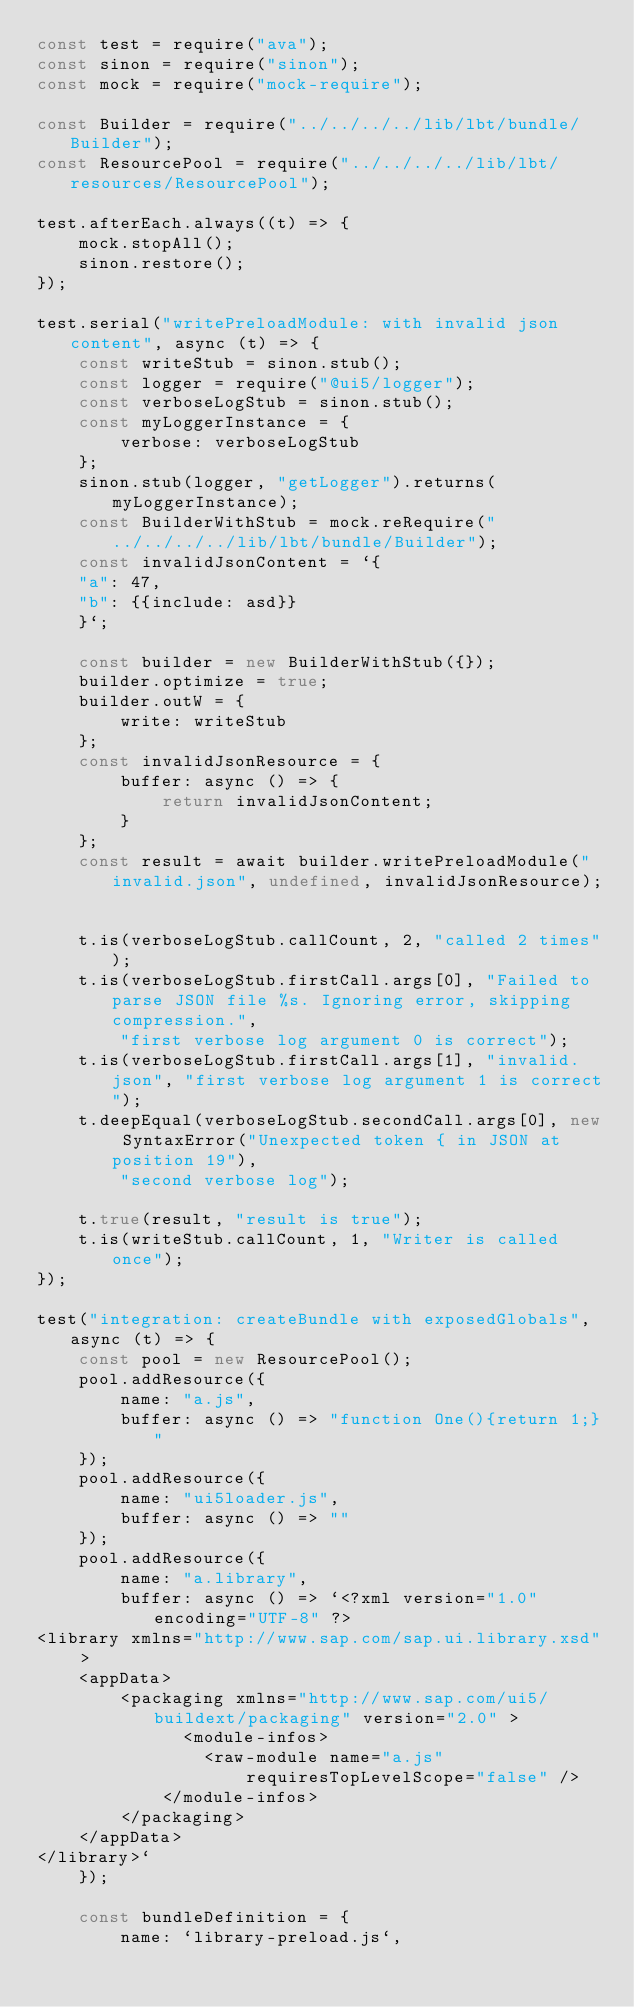<code> <loc_0><loc_0><loc_500><loc_500><_JavaScript_>const test = require("ava");
const sinon = require("sinon");
const mock = require("mock-require");

const Builder = require("../../../../lib/lbt/bundle/Builder");
const ResourcePool = require("../../../../lib/lbt/resources/ResourcePool");

test.afterEach.always((t) => {
	mock.stopAll();
	sinon.restore();
});

test.serial("writePreloadModule: with invalid json content", async (t) => {
	const writeStub = sinon.stub();
	const logger = require("@ui5/logger");
	const verboseLogStub = sinon.stub();
	const myLoggerInstance = {
		verbose: verboseLogStub
	};
	sinon.stub(logger, "getLogger").returns(myLoggerInstance);
	const BuilderWithStub = mock.reRequire("../../../../lib/lbt/bundle/Builder");
	const invalidJsonContent = `{
	"a": 47,
	"b": {{include: asd}}
	}`;

	const builder = new BuilderWithStub({});
	builder.optimize = true;
	builder.outW = {
		write: writeStub
	};
	const invalidJsonResource = {
		buffer: async () => {
			return invalidJsonContent;
		}
	};
	const result = await builder.writePreloadModule("invalid.json", undefined, invalidJsonResource);


	t.is(verboseLogStub.callCount, 2, "called 2 times");
	t.is(verboseLogStub.firstCall.args[0], "Failed to parse JSON file %s. Ignoring error, skipping compression.",
		"first verbose log argument 0 is correct");
	t.is(verboseLogStub.firstCall.args[1], "invalid.json", "first verbose log argument 1 is correct");
	t.deepEqual(verboseLogStub.secondCall.args[0], new SyntaxError("Unexpected token { in JSON at position 19"),
		"second verbose log");

	t.true(result, "result is true");
	t.is(writeStub.callCount, 1, "Writer is called once");
});

test("integration: createBundle with exposedGlobals", async (t) => {
	const pool = new ResourcePool();
	pool.addResource({
		name: "a.js",
		buffer: async () => "function One(){return 1;}"
	});
	pool.addResource({
		name: "ui5loader.js",
		buffer: async () => ""
	});
	pool.addResource({
		name: "a.library",
		buffer: async () => `<?xml version="1.0" encoding="UTF-8" ?>
<library xmlns="http://www.sap.com/sap.ui.library.xsd" >
	<appData>
		<packaging xmlns="http://www.sap.com/ui5/buildext/packaging" version="2.0" >
			  <module-infos>
				<raw-module name="a.js"
					requiresTopLevelScope="false" />
			</module-infos>
		</packaging>
	</appData>
</library>`
	});

	const bundleDefinition = {
		name: `library-preload.js`,</code> 